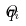<formula> <loc_0><loc_0><loc_500><loc_500>\hat { q } _ { i }</formula> 